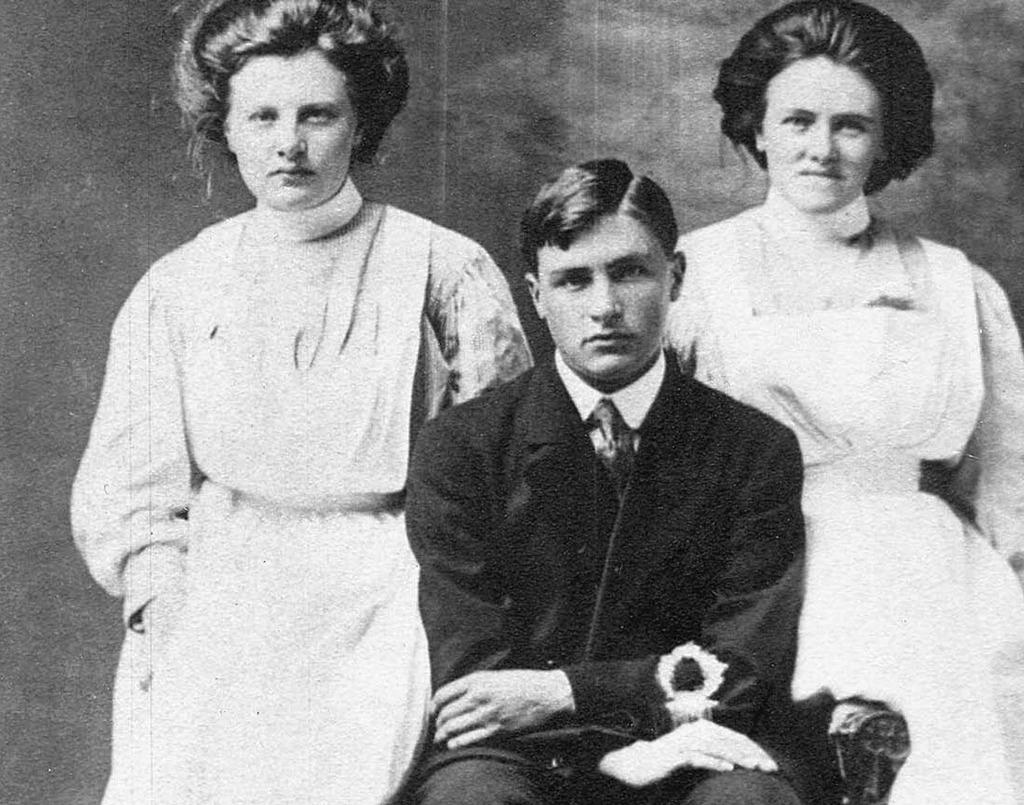What is the color scheme of the image? The image is black and white. What is the man in the image doing? The man is sitting on a chair in the image. Who is present with the man in the image? There are two women standing on either side of the man in the image. What are the women and the man doing together? The women and the man are posing for the picture. What type of coach is present in the image? There is no coach present in the image; it features a man sitting on a chair with two women standing on either side of him. What family theory is being demonstrated in the image? There is no family theory being demonstrated in the image; it simply shows a man and two women posing together. 